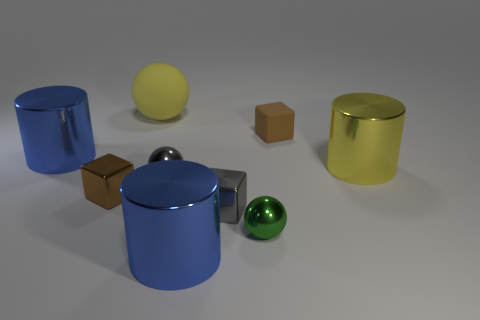What material is the yellow thing that is the same shape as the tiny green metal object?
Your answer should be compact. Rubber. What number of yellow objects are the same size as the green object?
Keep it short and to the point. 0. There is another small sphere that is made of the same material as the gray ball; what color is it?
Offer a very short reply. Green. Is the number of large yellow shiny things less than the number of small brown objects?
Offer a very short reply. Yes. What number of red things are cubes or big spheres?
Your answer should be compact. 0. How many big metallic objects are both on the right side of the big yellow sphere and left of the small green shiny sphere?
Offer a terse response. 1. Does the small gray cube have the same material as the small green object?
Offer a terse response. Yes. What is the shape of the yellow object that is the same size as the yellow shiny cylinder?
Ensure brevity in your answer.  Sphere. Are there more cyan shiny balls than brown metallic cubes?
Your answer should be compact. No. There is a small thing that is both to the left of the gray metallic block and behind the tiny brown metal cube; what is its material?
Provide a succinct answer. Metal. 